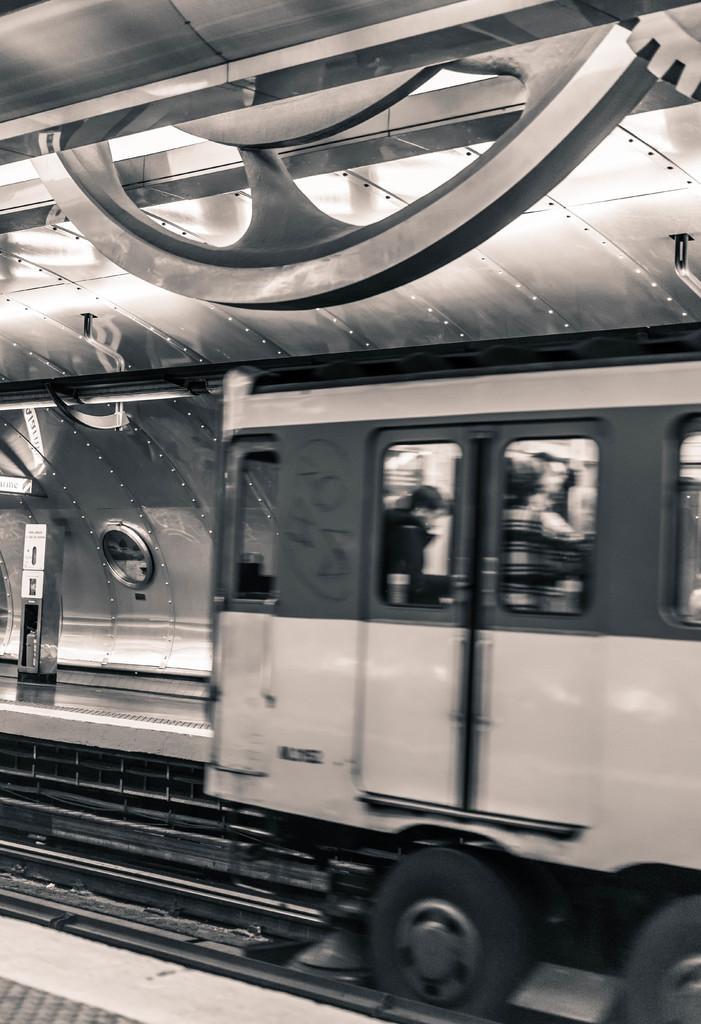Describe this image in one or two sentences. In this picture there are people in a train on railway track and we can see platform, shed and objects. 